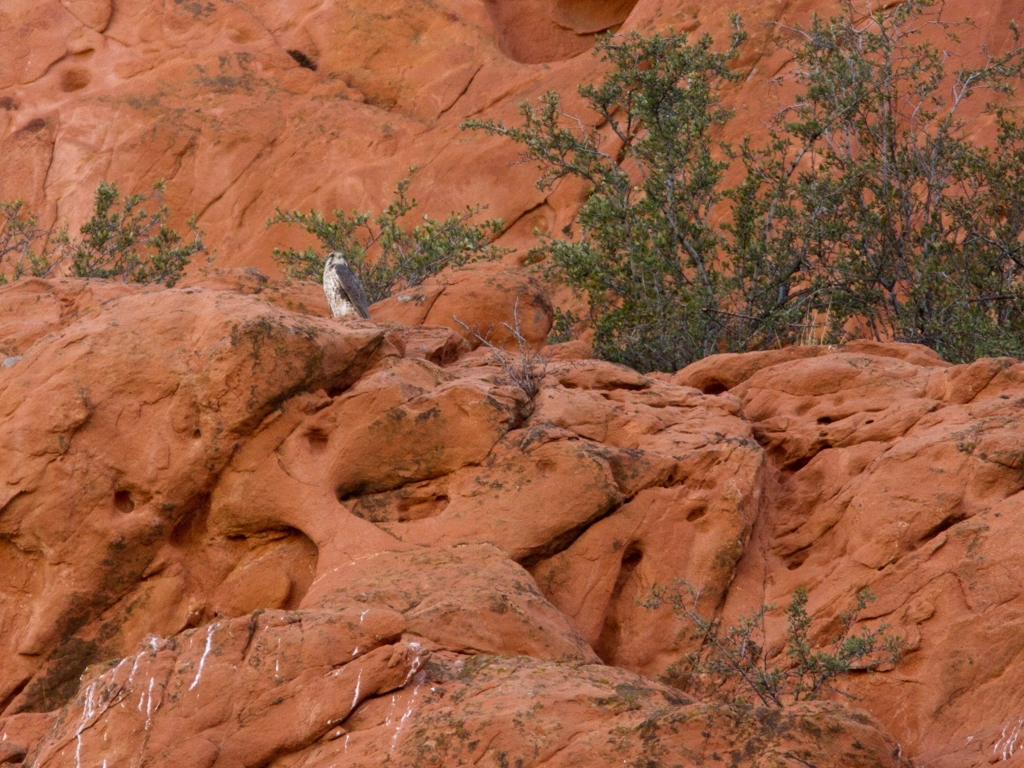What kind of landscape is shown in this image? The photo depicts a desert-like environment with red, eroded rock formations that suggest a natural arid area, possibly from a region similar to the Southwest United States. The sparse vegetation is typical of such climates. 